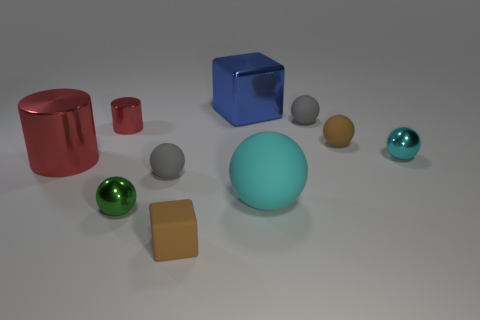Subtract all rubber balls. How many balls are left? 2 Subtract all brown spheres. How many spheres are left? 5 Subtract all cyan cubes. How many gray balls are left? 2 Subtract all cylinders. How many objects are left? 8 Subtract 4 balls. How many balls are left? 2 Subtract 0 yellow cylinders. How many objects are left? 10 Subtract all blue spheres. Subtract all purple cylinders. How many spheres are left? 6 Subtract all large blue rubber cubes. Subtract all big blue cubes. How many objects are left? 9 Add 5 small metallic cylinders. How many small metallic cylinders are left? 6 Add 3 small brown rubber objects. How many small brown rubber objects exist? 5 